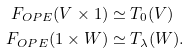Convert formula to latex. <formula><loc_0><loc_0><loc_500><loc_500>F _ { O P E } ( V \times 1 ) & \simeq T _ { 0 } ( V ) \\ F _ { O P E } ( 1 \times W ) & \simeq T _ { \lambda } ( W ) .</formula> 